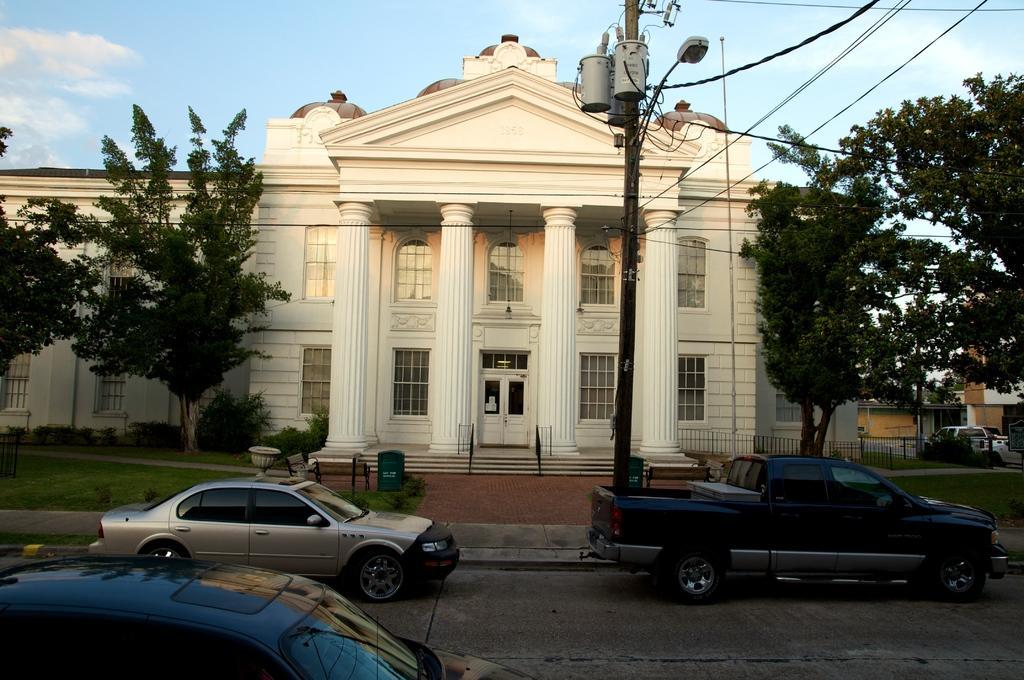Describe this image in one or two sentences. In the center of the image we can see a building, pillars, windows, door, stairs, railing, pole, light. In the background of the image we can see the trees, grass, fence, vehicles, building, boards, pot. At the bottom of the image we can see the road. At the top of the image we can see the wires and clouds in the sky. 